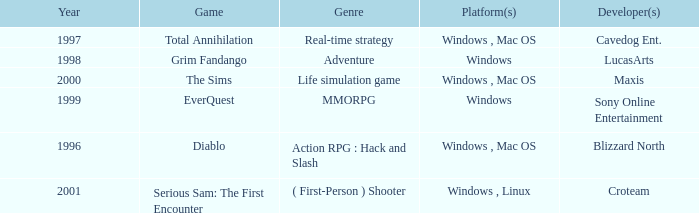What game in the genre of adventure, has a windows platform and its year is after 1997? Grim Fandango. 